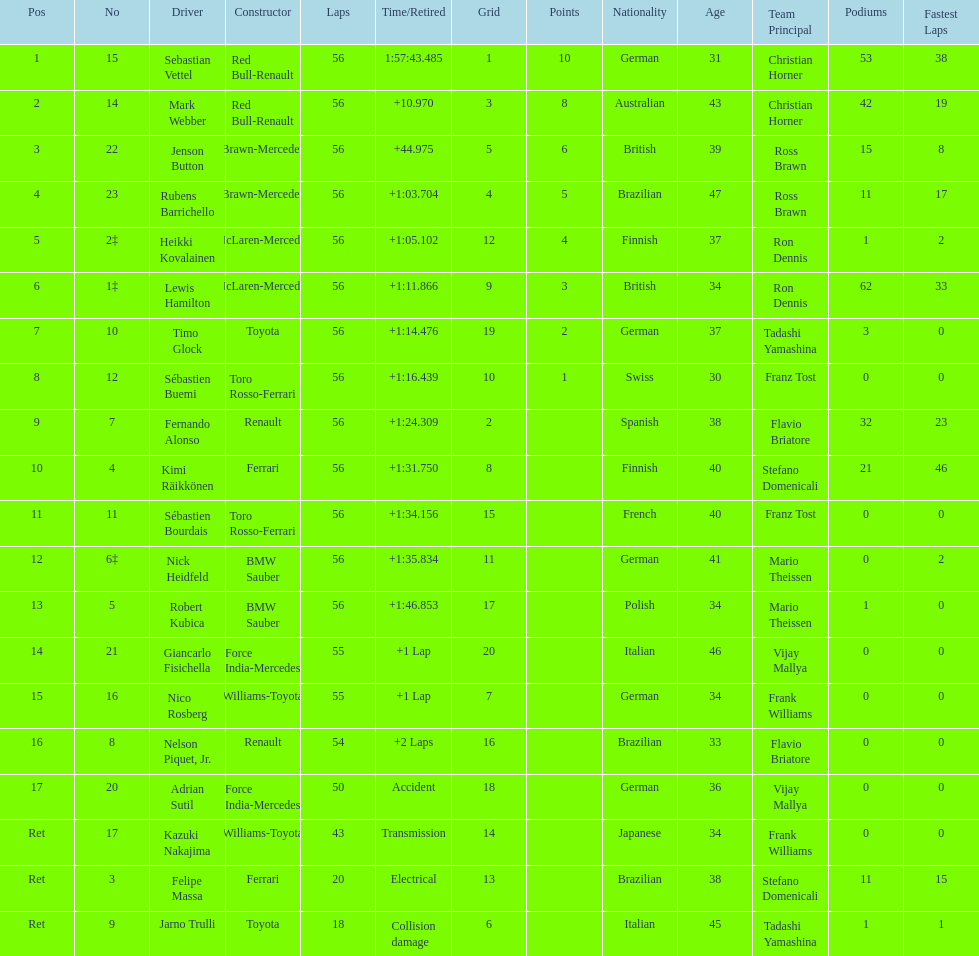What is the total number of drivers on the list? 20. 